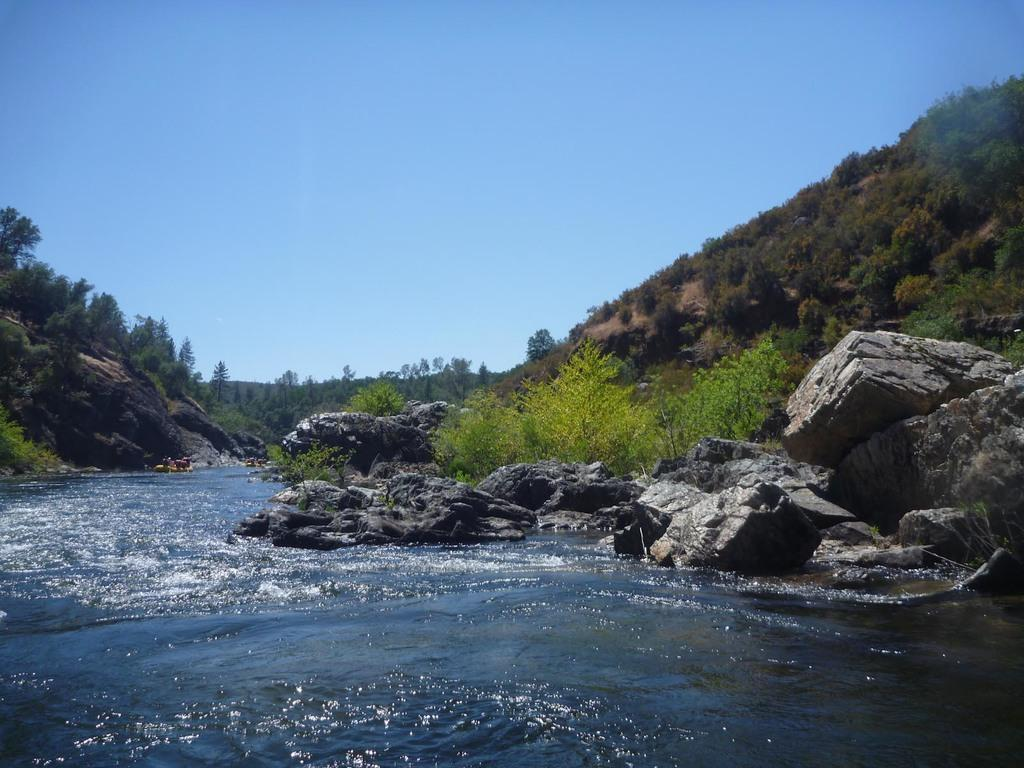What type of natural landscape can be seen in the image? There are hills in the image. What other elements are present in the landscape? There are rocks, water, trees, and plants visible in the image. What part of the natural environment is visible in the image? The sky is visible in the image. How many women are carrying bags in the image? There are no women or bags present in the image; it features a natural landscape with hills, rocks, water, trees, plants, and the sky. 